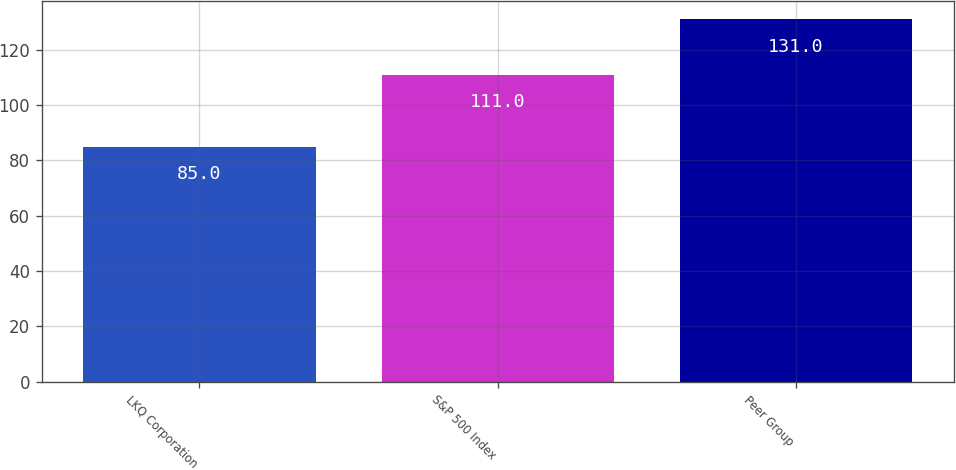<chart> <loc_0><loc_0><loc_500><loc_500><bar_chart><fcel>LKQ Corporation<fcel>S&P 500 Index<fcel>Peer Group<nl><fcel>85<fcel>111<fcel>131<nl></chart> 